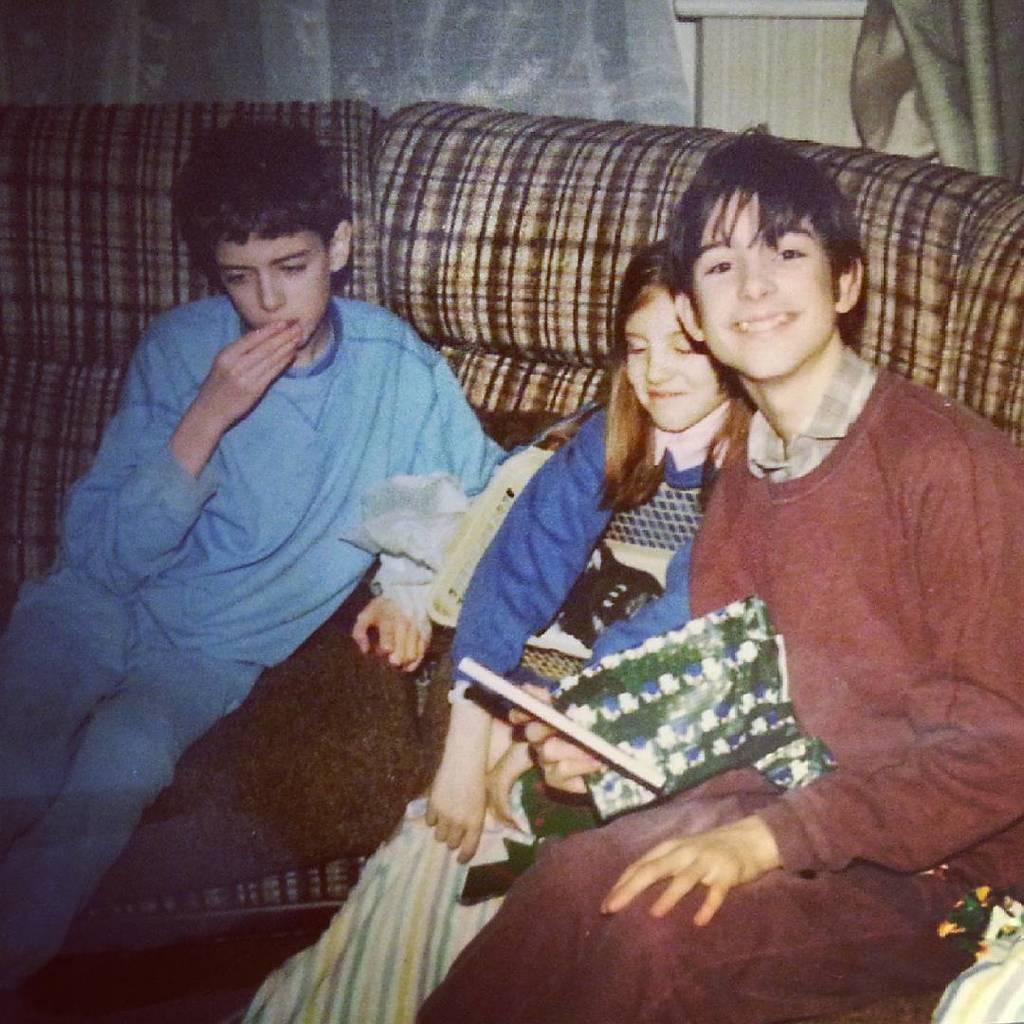Describe this image in one or two sentences. In this image we can see kids sitting on a sofa. In the background of the image there is curtain. 